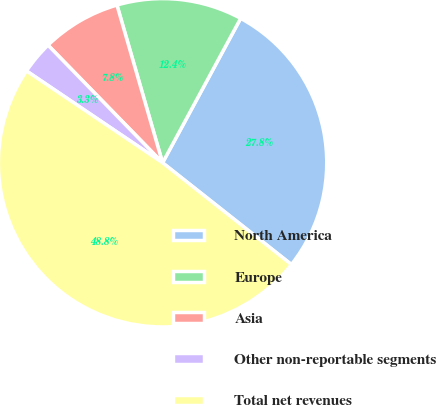Convert chart. <chart><loc_0><loc_0><loc_500><loc_500><pie_chart><fcel>North America<fcel>Europe<fcel>Asia<fcel>Other non-reportable segments<fcel>Total net revenues<nl><fcel>27.75%<fcel>12.37%<fcel>7.81%<fcel>3.26%<fcel>48.81%<nl></chart> 